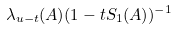Convert formula to latex. <formula><loc_0><loc_0><loc_500><loc_500>\lambda _ { u - t } ( A ) ( 1 - t S _ { 1 } ( A ) ) ^ { - 1 }</formula> 